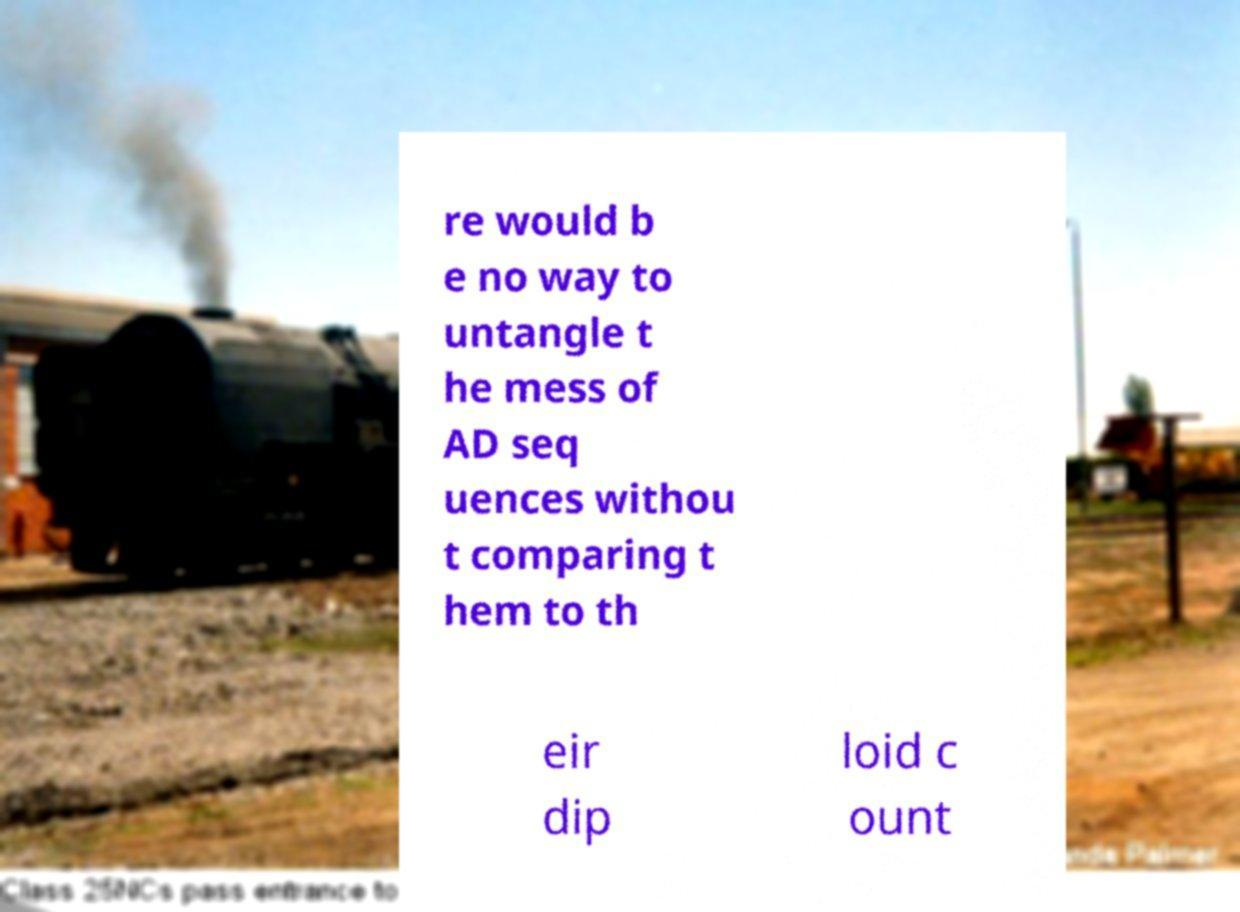Could you assist in decoding the text presented in this image and type it out clearly? re would b e no way to untangle t he mess of AD seq uences withou t comparing t hem to th eir dip loid c ount 